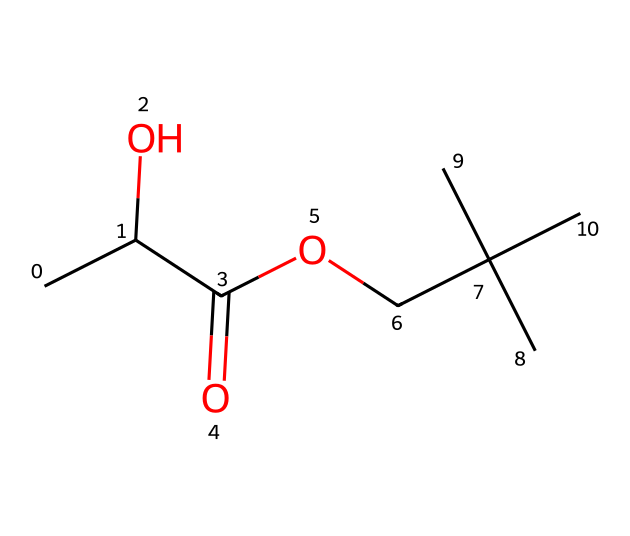What is the total number of carbon atoms in this molecule? Looking at the SMILES representation, there are three 'C' characters in the branches and the main chain. Counting them, we find a total of 5 carbon atoms in the molecule.
Answer: 5 What type of functional groups are present in this chemical? The visible parts of the SMILES include a carboxylic acid (C(=O)O) and an alcohol (C(O)). These functional groups identify it as an ester and acid.
Answer: carboxylic acid, alcohol How many oxygen atoms are present in this molecule? From the SMILES, we locate the 'O' characters. There are two oxygen atoms in the carboxylic acid group and one in the alcohol, totaling three oxygen atoms.
Answer: 3 Is this chemical biodegradable? Polylactic acid (PLA) is known for its biocompatibility and biodegradability due to its ester linkages and lactic acid origin.
Answer: yes What type of polymer is represented by this molecule? The chemical structure indicates it is derived from lactic acid units linked together, categorizing it as a polycondensate since it originates from the condensation reaction of lactic acid.
Answer: polycondensate Which part of the molecule contributes to its flexibility? The ester linkages in the molecular structure provide flexibility to the polymer chains due to their capacity to rotate around the carbon-oxygen bonds.
Answer: ester linkages What is the degree of unsaturation in this molecule? Analyzing the structure, we check for double bonds or rings. There’s one double bond in the contained carboxylic acid (C=O) and no rings, which gives a degree of unsaturation of 1.
Answer: 1 